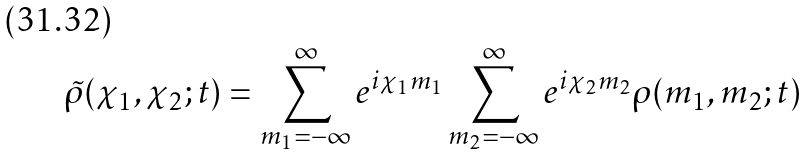<formula> <loc_0><loc_0><loc_500><loc_500>\tilde { \rho } ( \chi _ { 1 } , \chi _ { 2 } ; t ) = \sum _ { m _ { 1 } = - \infty } ^ { \infty } e ^ { i \chi _ { 1 } m _ { 1 } } \sum _ { m _ { 2 } = - \infty } ^ { \infty } e ^ { i \chi _ { 2 } m _ { 2 } } \rho ( m _ { 1 } , m _ { 2 } ; t )</formula> 